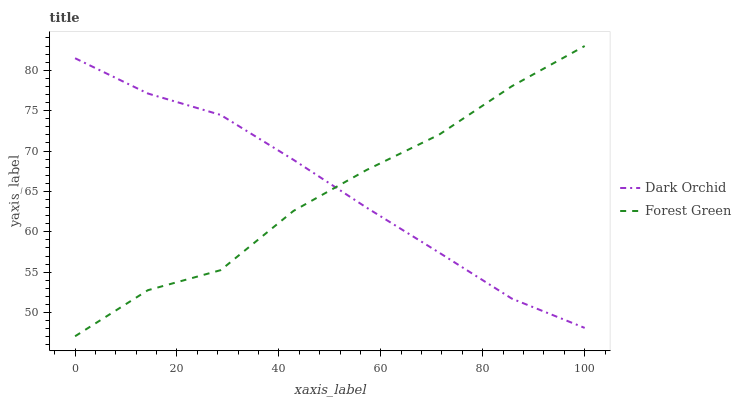Does Forest Green have the minimum area under the curve?
Answer yes or no. Yes. Does Dark Orchid have the maximum area under the curve?
Answer yes or no. Yes. Does Dark Orchid have the minimum area under the curve?
Answer yes or no. No. Is Dark Orchid the smoothest?
Answer yes or no. Yes. Is Forest Green the roughest?
Answer yes or no. Yes. Is Dark Orchid the roughest?
Answer yes or no. No. Does Forest Green have the lowest value?
Answer yes or no. Yes. Does Dark Orchid have the lowest value?
Answer yes or no. No. Does Forest Green have the highest value?
Answer yes or no. Yes. Does Dark Orchid have the highest value?
Answer yes or no. No. Does Dark Orchid intersect Forest Green?
Answer yes or no. Yes. Is Dark Orchid less than Forest Green?
Answer yes or no. No. Is Dark Orchid greater than Forest Green?
Answer yes or no. No. 